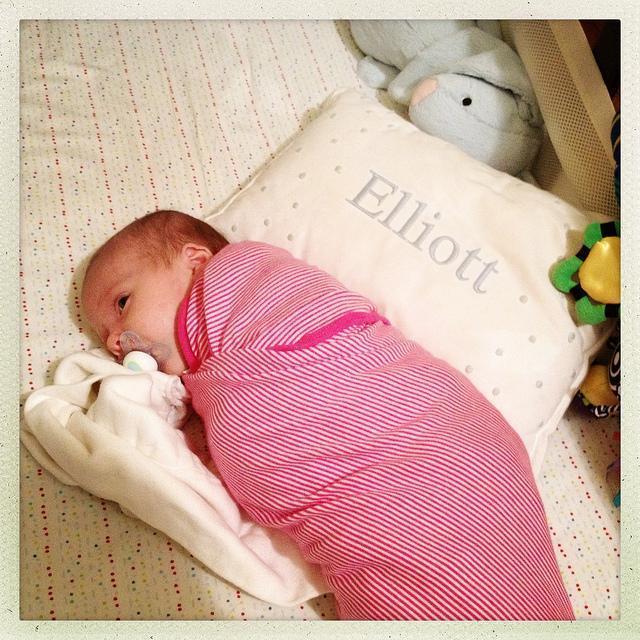How many teddy bears can be seen?
Give a very brief answer. 2. How many chairs or sofas have a red pillow?
Give a very brief answer. 0. 